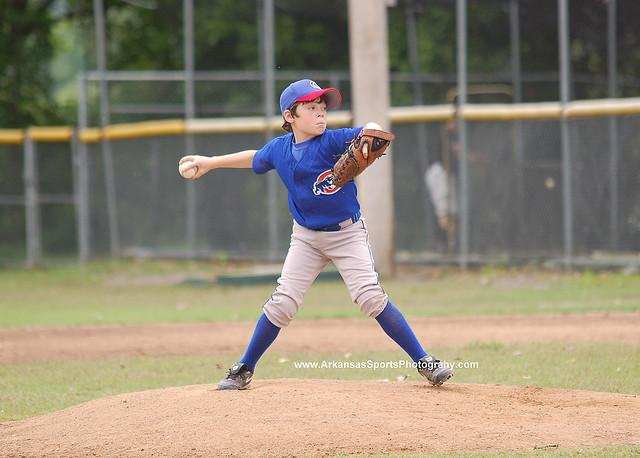Where does the URL text actually exist? online 